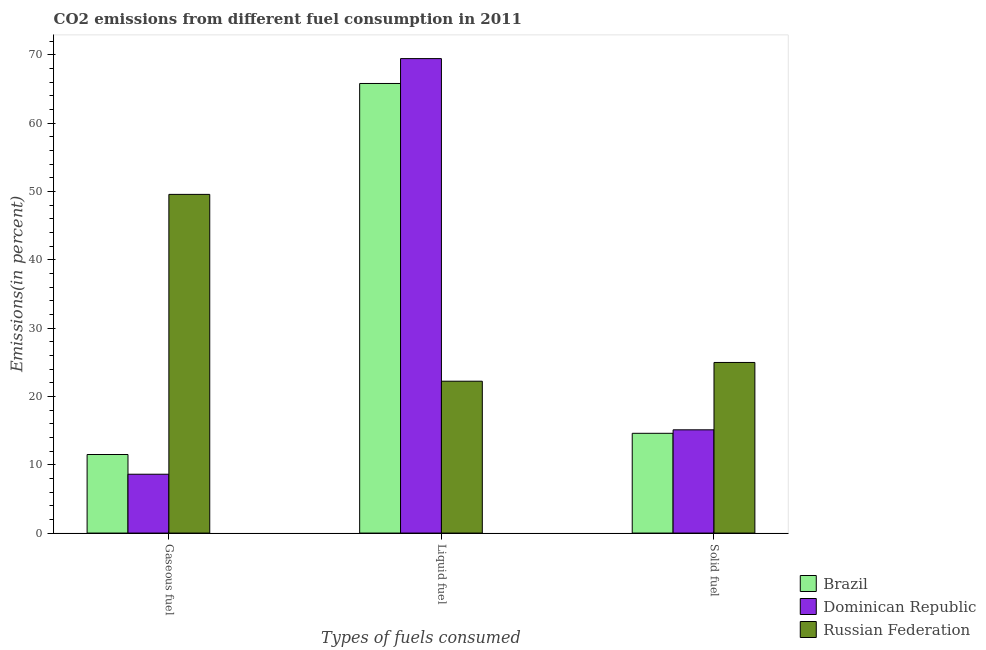How many different coloured bars are there?
Give a very brief answer. 3. Are the number of bars on each tick of the X-axis equal?
Your answer should be compact. Yes. What is the label of the 2nd group of bars from the left?
Your response must be concise. Liquid fuel. What is the percentage of solid fuel emission in Russian Federation?
Your answer should be compact. 24.97. Across all countries, what is the maximum percentage of gaseous fuel emission?
Offer a very short reply. 49.57. Across all countries, what is the minimum percentage of liquid fuel emission?
Ensure brevity in your answer.  22.23. In which country was the percentage of solid fuel emission maximum?
Keep it short and to the point. Russian Federation. In which country was the percentage of liquid fuel emission minimum?
Offer a terse response. Russian Federation. What is the total percentage of gaseous fuel emission in the graph?
Your answer should be compact. 69.68. What is the difference between the percentage of solid fuel emission in Brazil and that in Russian Federation?
Your response must be concise. -10.37. What is the difference between the percentage of gaseous fuel emission in Russian Federation and the percentage of solid fuel emission in Brazil?
Ensure brevity in your answer.  34.97. What is the average percentage of gaseous fuel emission per country?
Keep it short and to the point. 23.23. What is the difference between the percentage of gaseous fuel emission and percentage of liquid fuel emission in Brazil?
Provide a succinct answer. -54.3. What is the ratio of the percentage of solid fuel emission in Russian Federation to that in Dominican Republic?
Your response must be concise. 1.65. Is the difference between the percentage of gaseous fuel emission in Brazil and Russian Federation greater than the difference between the percentage of solid fuel emission in Brazil and Russian Federation?
Your answer should be compact. No. What is the difference between the highest and the second highest percentage of solid fuel emission?
Your answer should be compact. 9.86. What is the difference between the highest and the lowest percentage of liquid fuel emission?
Offer a very short reply. 47.22. Is the sum of the percentage of solid fuel emission in Russian Federation and Dominican Republic greater than the maximum percentage of liquid fuel emission across all countries?
Your answer should be very brief. No. What does the 2nd bar from the left in Liquid fuel represents?
Provide a short and direct response. Dominican Republic. What does the 3rd bar from the right in Gaseous fuel represents?
Give a very brief answer. Brazil. Is it the case that in every country, the sum of the percentage of gaseous fuel emission and percentage of liquid fuel emission is greater than the percentage of solid fuel emission?
Your answer should be compact. Yes. Are all the bars in the graph horizontal?
Your response must be concise. No. Are the values on the major ticks of Y-axis written in scientific E-notation?
Ensure brevity in your answer.  No. Does the graph contain grids?
Make the answer very short. No. What is the title of the graph?
Offer a very short reply. CO2 emissions from different fuel consumption in 2011. Does "United Arab Emirates" appear as one of the legend labels in the graph?
Provide a succinct answer. No. What is the label or title of the X-axis?
Ensure brevity in your answer.  Types of fuels consumed. What is the label or title of the Y-axis?
Keep it short and to the point. Emissions(in percent). What is the Emissions(in percent) of Brazil in Gaseous fuel?
Offer a very short reply. 11.5. What is the Emissions(in percent) in Dominican Republic in Gaseous fuel?
Offer a terse response. 8.61. What is the Emissions(in percent) of Russian Federation in Gaseous fuel?
Your answer should be compact. 49.57. What is the Emissions(in percent) of Brazil in Liquid fuel?
Your answer should be compact. 65.8. What is the Emissions(in percent) in Dominican Republic in Liquid fuel?
Ensure brevity in your answer.  69.44. What is the Emissions(in percent) of Russian Federation in Liquid fuel?
Make the answer very short. 22.23. What is the Emissions(in percent) of Brazil in Solid fuel?
Make the answer very short. 14.6. What is the Emissions(in percent) of Dominican Republic in Solid fuel?
Your response must be concise. 15.11. What is the Emissions(in percent) of Russian Federation in Solid fuel?
Make the answer very short. 24.97. Across all Types of fuels consumed, what is the maximum Emissions(in percent) in Brazil?
Give a very brief answer. 65.8. Across all Types of fuels consumed, what is the maximum Emissions(in percent) of Dominican Republic?
Keep it short and to the point. 69.44. Across all Types of fuels consumed, what is the maximum Emissions(in percent) in Russian Federation?
Offer a very short reply. 49.57. Across all Types of fuels consumed, what is the minimum Emissions(in percent) in Brazil?
Your response must be concise. 11.5. Across all Types of fuels consumed, what is the minimum Emissions(in percent) in Dominican Republic?
Give a very brief answer. 8.61. Across all Types of fuels consumed, what is the minimum Emissions(in percent) of Russian Federation?
Keep it short and to the point. 22.23. What is the total Emissions(in percent) in Brazil in the graph?
Offer a very short reply. 91.9. What is the total Emissions(in percent) in Dominican Republic in the graph?
Keep it short and to the point. 93.16. What is the total Emissions(in percent) of Russian Federation in the graph?
Your answer should be very brief. 96.77. What is the difference between the Emissions(in percent) in Brazil in Gaseous fuel and that in Liquid fuel?
Your answer should be very brief. -54.3. What is the difference between the Emissions(in percent) of Dominican Republic in Gaseous fuel and that in Liquid fuel?
Provide a short and direct response. -60.83. What is the difference between the Emissions(in percent) in Russian Federation in Gaseous fuel and that in Liquid fuel?
Provide a succinct answer. 27.34. What is the difference between the Emissions(in percent) of Brazil in Gaseous fuel and that in Solid fuel?
Ensure brevity in your answer.  -3.1. What is the difference between the Emissions(in percent) in Dominican Republic in Gaseous fuel and that in Solid fuel?
Your answer should be compact. -6.5. What is the difference between the Emissions(in percent) of Russian Federation in Gaseous fuel and that in Solid fuel?
Offer a terse response. 24.6. What is the difference between the Emissions(in percent) in Brazil in Liquid fuel and that in Solid fuel?
Your response must be concise. 51.2. What is the difference between the Emissions(in percent) of Dominican Republic in Liquid fuel and that in Solid fuel?
Your answer should be very brief. 54.33. What is the difference between the Emissions(in percent) in Russian Federation in Liquid fuel and that in Solid fuel?
Keep it short and to the point. -2.75. What is the difference between the Emissions(in percent) in Brazil in Gaseous fuel and the Emissions(in percent) in Dominican Republic in Liquid fuel?
Give a very brief answer. -57.94. What is the difference between the Emissions(in percent) in Brazil in Gaseous fuel and the Emissions(in percent) in Russian Federation in Liquid fuel?
Offer a terse response. -10.73. What is the difference between the Emissions(in percent) of Dominican Republic in Gaseous fuel and the Emissions(in percent) of Russian Federation in Liquid fuel?
Keep it short and to the point. -13.61. What is the difference between the Emissions(in percent) of Brazil in Gaseous fuel and the Emissions(in percent) of Dominican Republic in Solid fuel?
Offer a very short reply. -3.61. What is the difference between the Emissions(in percent) of Brazil in Gaseous fuel and the Emissions(in percent) of Russian Federation in Solid fuel?
Provide a short and direct response. -13.47. What is the difference between the Emissions(in percent) of Dominican Republic in Gaseous fuel and the Emissions(in percent) of Russian Federation in Solid fuel?
Keep it short and to the point. -16.36. What is the difference between the Emissions(in percent) of Brazil in Liquid fuel and the Emissions(in percent) of Dominican Republic in Solid fuel?
Keep it short and to the point. 50.69. What is the difference between the Emissions(in percent) of Brazil in Liquid fuel and the Emissions(in percent) of Russian Federation in Solid fuel?
Give a very brief answer. 40.83. What is the difference between the Emissions(in percent) in Dominican Republic in Liquid fuel and the Emissions(in percent) in Russian Federation in Solid fuel?
Make the answer very short. 44.47. What is the average Emissions(in percent) of Brazil per Types of fuels consumed?
Offer a terse response. 30.63. What is the average Emissions(in percent) of Dominican Republic per Types of fuels consumed?
Keep it short and to the point. 31.05. What is the average Emissions(in percent) of Russian Federation per Types of fuels consumed?
Your response must be concise. 32.26. What is the difference between the Emissions(in percent) of Brazil and Emissions(in percent) of Dominican Republic in Gaseous fuel?
Provide a short and direct response. 2.89. What is the difference between the Emissions(in percent) in Brazil and Emissions(in percent) in Russian Federation in Gaseous fuel?
Ensure brevity in your answer.  -38.07. What is the difference between the Emissions(in percent) of Dominican Republic and Emissions(in percent) of Russian Federation in Gaseous fuel?
Your response must be concise. -40.96. What is the difference between the Emissions(in percent) of Brazil and Emissions(in percent) of Dominican Republic in Liquid fuel?
Offer a very short reply. -3.64. What is the difference between the Emissions(in percent) of Brazil and Emissions(in percent) of Russian Federation in Liquid fuel?
Provide a succinct answer. 43.58. What is the difference between the Emissions(in percent) of Dominican Republic and Emissions(in percent) of Russian Federation in Liquid fuel?
Keep it short and to the point. 47.22. What is the difference between the Emissions(in percent) of Brazil and Emissions(in percent) of Dominican Republic in Solid fuel?
Make the answer very short. -0.51. What is the difference between the Emissions(in percent) in Brazil and Emissions(in percent) in Russian Federation in Solid fuel?
Make the answer very short. -10.37. What is the difference between the Emissions(in percent) of Dominican Republic and Emissions(in percent) of Russian Federation in Solid fuel?
Your answer should be compact. -9.86. What is the ratio of the Emissions(in percent) of Brazil in Gaseous fuel to that in Liquid fuel?
Make the answer very short. 0.17. What is the ratio of the Emissions(in percent) of Dominican Republic in Gaseous fuel to that in Liquid fuel?
Ensure brevity in your answer.  0.12. What is the ratio of the Emissions(in percent) in Russian Federation in Gaseous fuel to that in Liquid fuel?
Your response must be concise. 2.23. What is the ratio of the Emissions(in percent) of Brazil in Gaseous fuel to that in Solid fuel?
Offer a very short reply. 0.79. What is the ratio of the Emissions(in percent) of Dominican Republic in Gaseous fuel to that in Solid fuel?
Offer a terse response. 0.57. What is the ratio of the Emissions(in percent) in Russian Federation in Gaseous fuel to that in Solid fuel?
Provide a short and direct response. 1.99. What is the ratio of the Emissions(in percent) of Brazil in Liquid fuel to that in Solid fuel?
Offer a terse response. 4.51. What is the ratio of the Emissions(in percent) in Dominican Republic in Liquid fuel to that in Solid fuel?
Offer a very short reply. 4.6. What is the ratio of the Emissions(in percent) of Russian Federation in Liquid fuel to that in Solid fuel?
Provide a short and direct response. 0.89. What is the difference between the highest and the second highest Emissions(in percent) of Brazil?
Make the answer very short. 51.2. What is the difference between the highest and the second highest Emissions(in percent) in Dominican Republic?
Provide a short and direct response. 54.33. What is the difference between the highest and the second highest Emissions(in percent) of Russian Federation?
Your answer should be compact. 24.6. What is the difference between the highest and the lowest Emissions(in percent) of Brazil?
Give a very brief answer. 54.3. What is the difference between the highest and the lowest Emissions(in percent) of Dominican Republic?
Provide a succinct answer. 60.83. What is the difference between the highest and the lowest Emissions(in percent) of Russian Federation?
Provide a succinct answer. 27.34. 